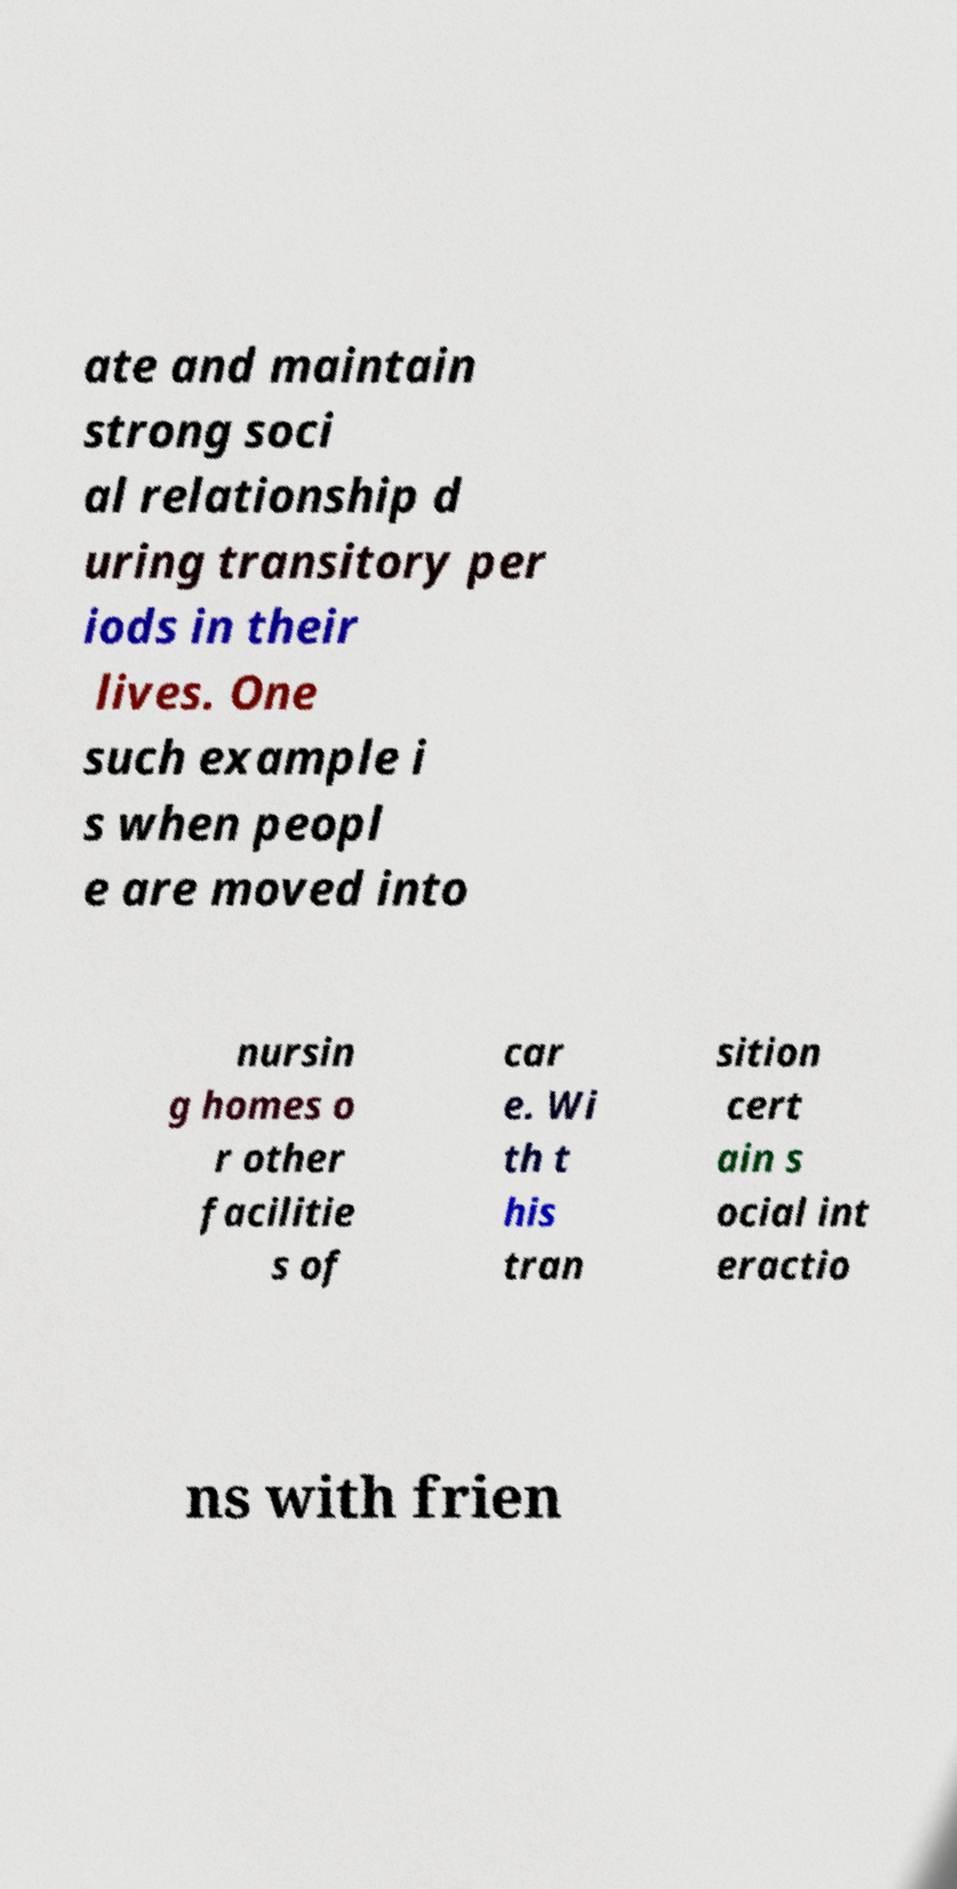Can you accurately transcribe the text from the provided image for me? ate and maintain strong soci al relationship d uring transitory per iods in their lives. One such example i s when peopl e are moved into nursin g homes o r other facilitie s of car e. Wi th t his tran sition cert ain s ocial int eractio ns with frien 